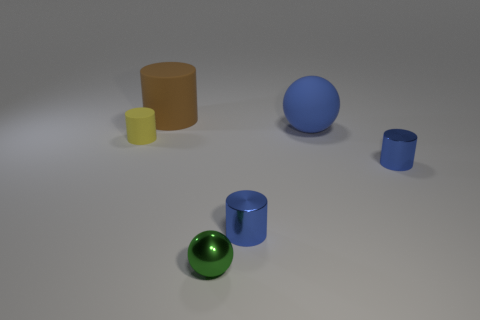The large thing right of the cylinder that is behind the cylinder that is left of the brown rubber cylinder is what color? The object you're inquiring about appears to be a large blue sphere. It is positioned to the right of a cylinder and behind another cylinder that is situated left of a brown rubbery-looking cylinder. 